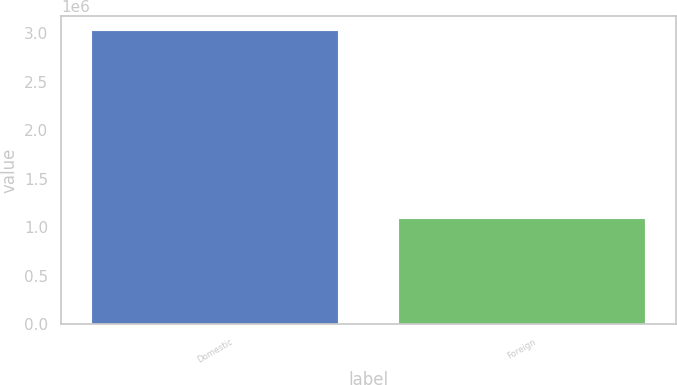<chart> <loc_0><loc_0><loc_500><loc_500><bar_chart><fcel>Domestic<fcel>Foreign<nl><fcel>3.02227e+06<fcel>1.08894e+06<nl></chart> 